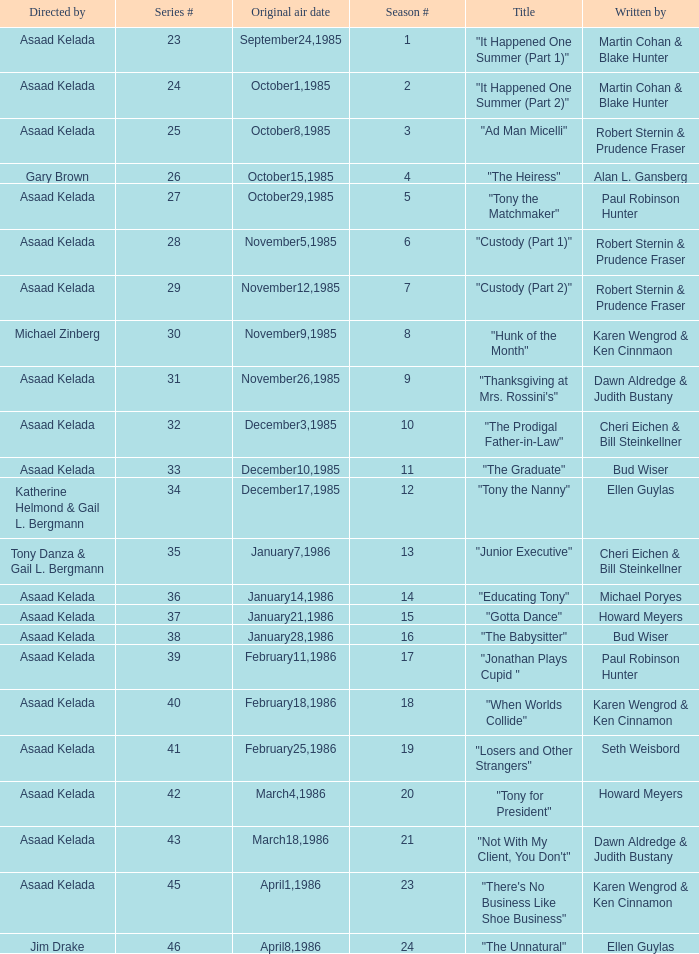What is the date of the episode written by Michael Poryes? January14,1986. 